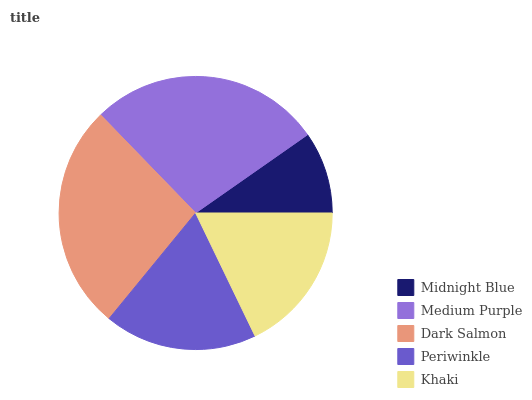Is Midnight Blue the minimum?
Answer yes or no. Yes. Is Medium Purple the maximum?
Answer yes or no. Yes. Is Dark Salmon the minimum?
Answer yes or no. No. Is Dark Salmon the maximum?
Answer yes or no. No. Is Medium Purple greater than Dark Salmon?
Answer yes or no. Yes. Is Dark Salmon less than Medium Purple?
Answer yes or no. Yes. Is Dark Salmon greater than Medium Purple?
Answer yes or no. No. Is Medium Purple less than Dark Salmon?
Answer yes or no. No. Is Periwinkle the high median?
Answer yes or no. Yes. Is Periwinkle the low median?
Answer yes or no. Yes. Is Midnight Blue the high median?
Answer yes or no. No. Is Medium Purple the low median?
Answer yes or no. No. 